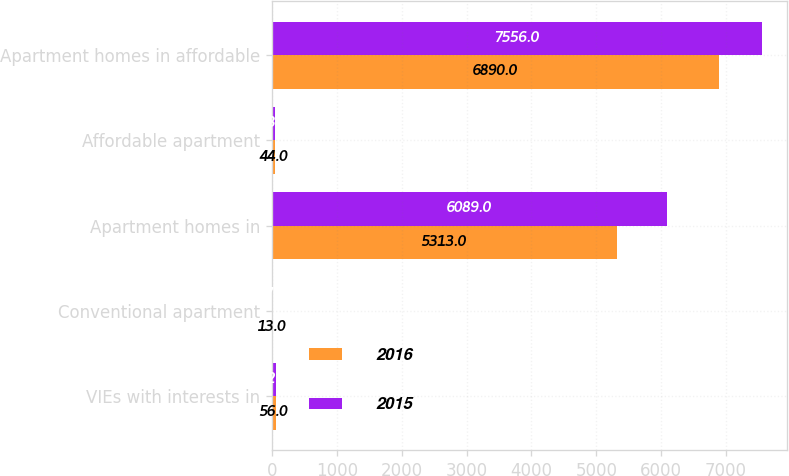Convert chart. <chart><loc_0><loc_0><loc_500><loc_500><stacked_bar_chart><ecel><fcel>VIEs with interests in<fcel>Conventional apartment<fcel>Apartment homes in<fcel>Affordable apartment<fcel>Apartment homes in affordable<nl><fcel>2016<fcel>56<fcel>13<fcel>5313<fcel>44<fcel>6890<nl><fcel>2015<fcel>62<fcel>17<fcel>6089<fcel>48<fcel>7556<nl></chart> 